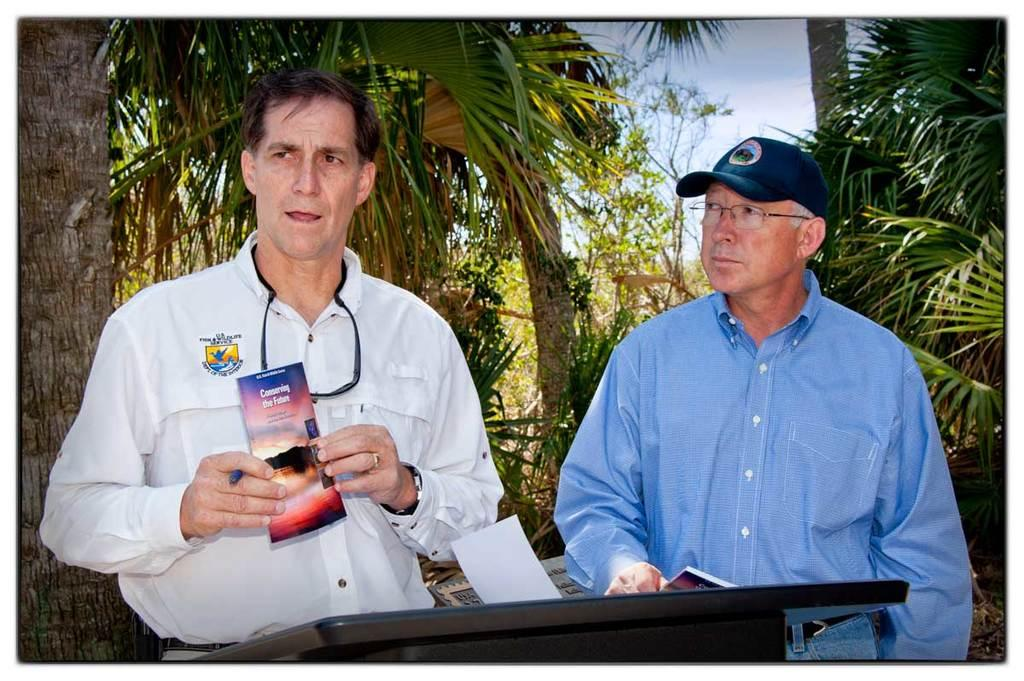How many people are in the image? There are two persons in the image. What is the position of one of the persons? One person is standing. What are the two persons holding? Both persons are holding the same object. What can be seen in the background of the image? There are groups of trees in the background of the image. What type of humor is being displayed by the person in the front of the image? There is no indication of humor in the image, and the concept of a "front" person is not applicable since both persons are holding the same object. 